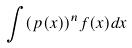Convert formula to latex. <formula><loc_0><loc_0><loc_500><loc_500>\int ( p ( x ) ) ^ { n } f ( x ) d x</formula> 